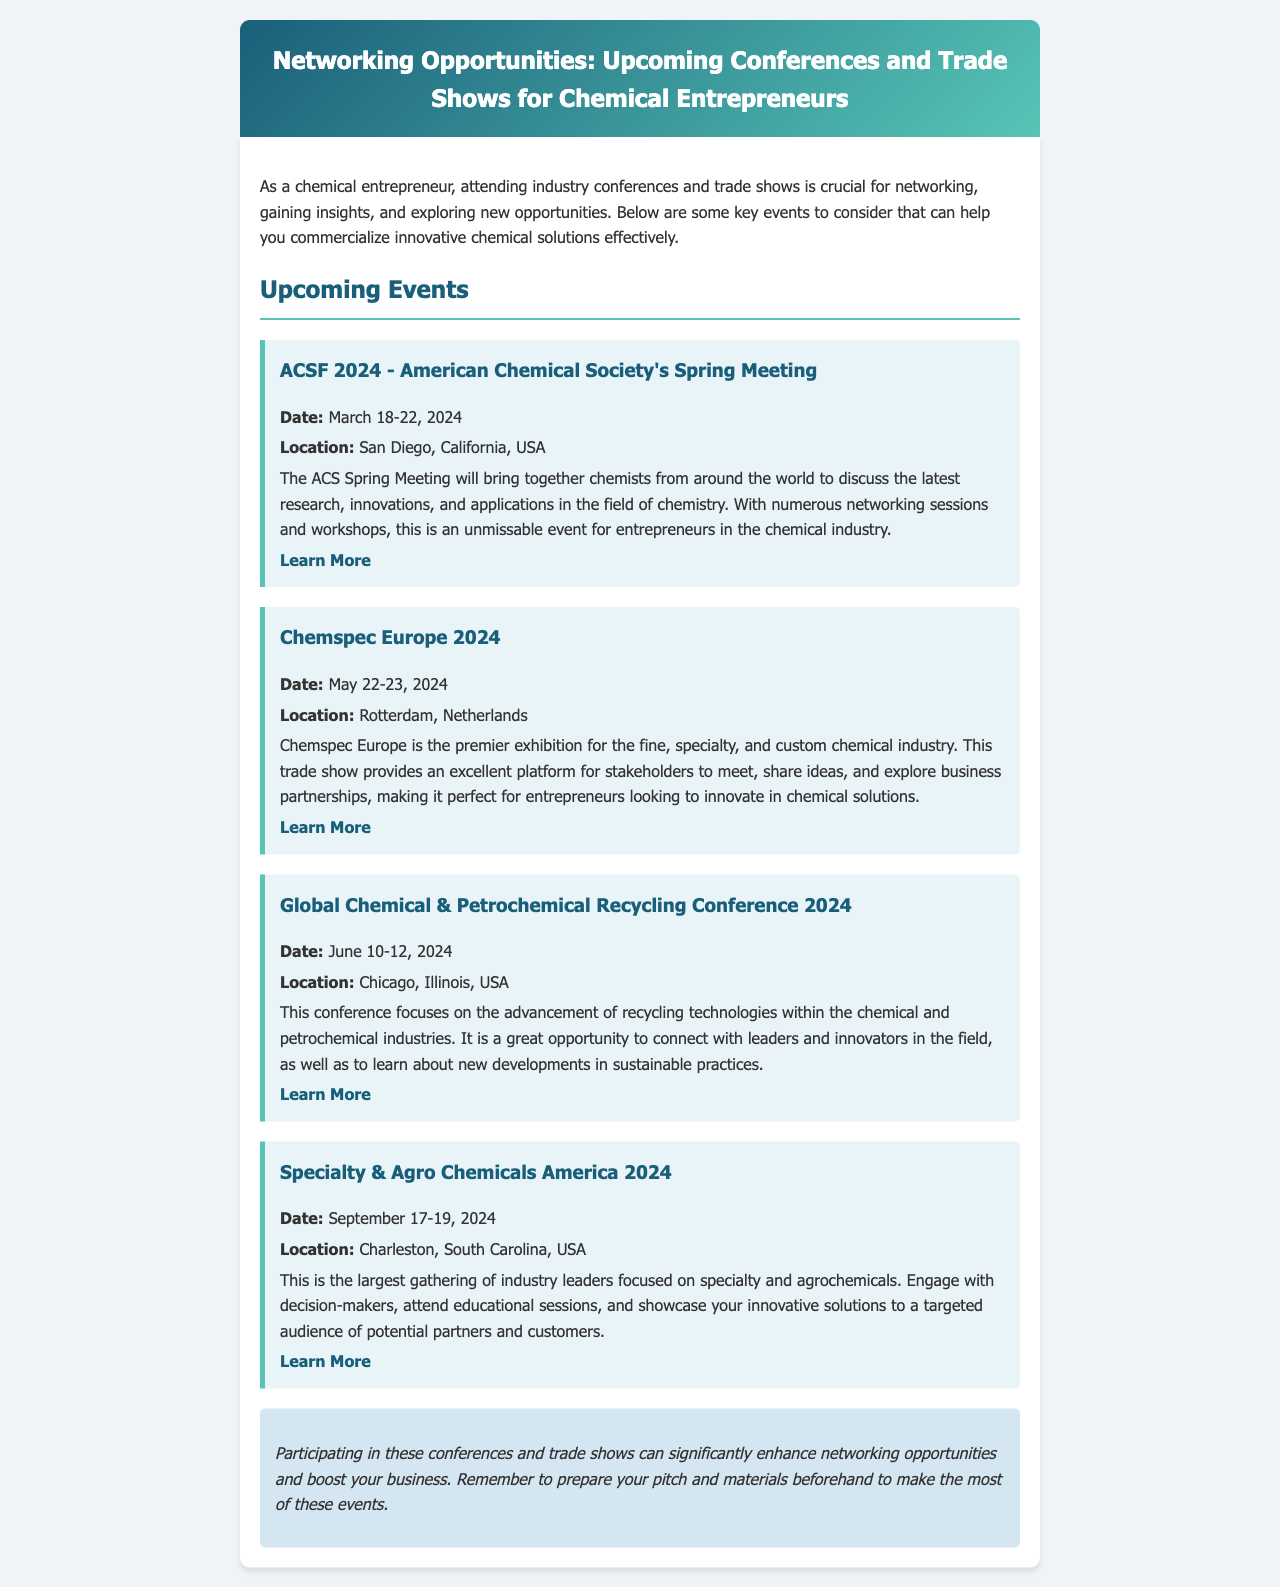What is the date of ACSF 2024? The date of ACSF 2024 is provided in the document as March 18-22, 2024.
Answer: March 18-22, 2024 Where is Chemspec Europe 2024 being held? The location for Chemspec Europe 2024 is mentioned as Rotterdam, Netherlands.
Answer: Rotterdam, Netherlands Which conference focuses on recycling technologies? The document specifies that the Global Chemical & Petrochemical Recycling Conference is focused on recycling technologies.
Answer: Global Chemical & Petrochemical Recycling Conference How many days does Specialty & Agro Chemicals America 2024 last? The document states that it runs from September 17-19, 2024, which is a total of three days.
Answer: 3 days What is the main theme of the Global Chemical & Petrochemical Recycling Conference? The document describes the main theme as the advancement of recycling technologies.
Answer: Advancement of recycling technologies What color is the header background? The document visually presents the header background as a gradient of two colors: #1a5f7a and #57c5b6.
Answer: Gradient of #1a5f7a and #57c5b6 Why should entrepreneurs attend these conferences? The document lists networking opportunities and insights as key reasons for attendance.
Answer: Networking opportunities and insights What type of event is Chemspec Europe? The document classifies Chemspec Europe as a premier exhibition for the fine, specialty, and custom chemical industry.
Answer: Premier exhibition What is encouraged to prepare for these events? The document suggests preparing your pitch and materials beforehand.
Answer: Your pitch and materials 